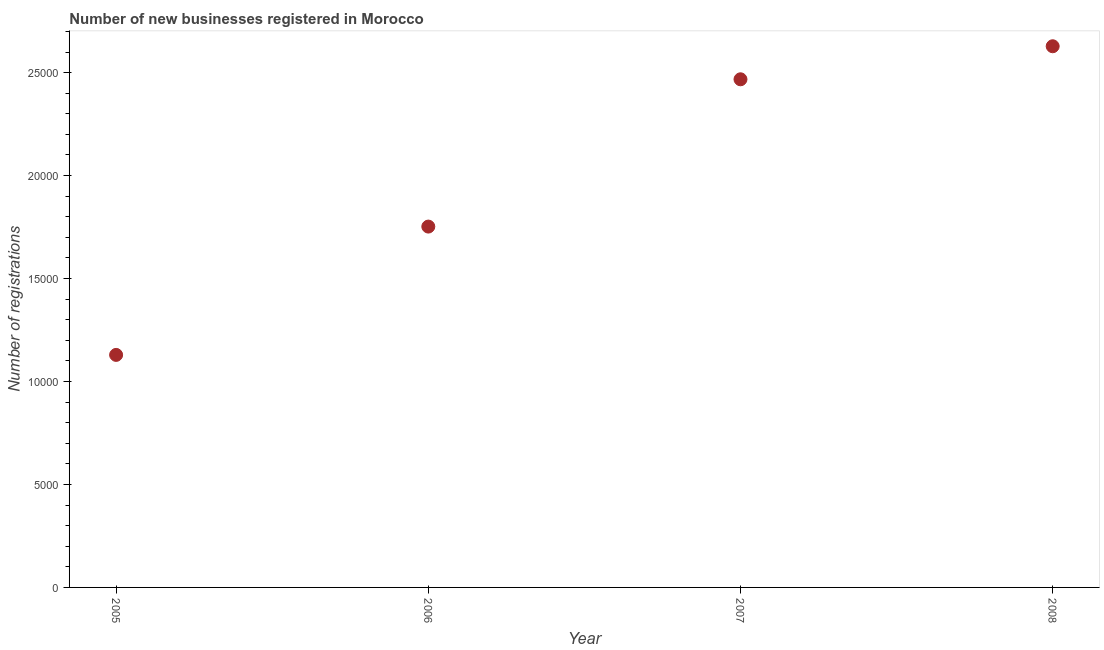What is the number of new business registrations in 2007?
Give a very brief answer. 2.47e+04. Across all years, what is the maximum number of new business registrations?
Your answer should be compact. 2.63e+04. Across all years, what is the minimum number of new business registrations?
Give a very brief answer. 1.13e+04. In which year was the number of new business registrations maximum?
Your answer should be compact. 2008. In which year was the number of new business registrations minimum?
Provide a short and direct response. 2005. What is the sum of the number of new business registrations?
Offer a very short reply. 7.98e+04. What is the difference between the number of new business registrations in 2005 and 2007?
Your answer should be compact. -1.34e+04. What is the average number of new business registrations per year?
Your answer should be compact. 1.99e+04. What is the median number of new business registrations?
Make the answer very short. 2.11e+04. In how many years, is the number of new business registrations greater than 26000 ?
Your answer should be compact. 1. Do a majority of the years between 2006 and 2007 (inclusive) have number of new business registrations greater than 18000 ?
Your answer should be very brief. No. What is the ratio of the number of new business registrations in 2005 to that in 2006?
Your answer should be compact. 0.64. What is the difference between the highest and the second highest number of new business registrations?
Give a very brief answer. 1604. What is the difference between the highest and the lowest number of new business registrations?
Keep it short and to the point. 1.50e+04. In how many years, is the number of new business registrations greater than the average number of new business registrations taken over all years?
Ensure brevity in your answer.  2. How many years are there in the graph?
Give a very brief answer. 4. What is the difference between two consecutive major ticks on the Y-axis?
Give a very brief answer. 5000. Does the graph contain grids?
Provide a short and direct response. No. What is the title of the graph?
Your answer should be compact. Number of new businesses registered in Morocco. What is the label or title of the X-axis?
Your response must be concise. Year. What is the label or title of the Y-axis?
Provide a succinct answer. Number of registrations. What is the Number of registrations in 2005?
Keep it short and to the point. 1.13e+04. What is the Number of registrations in 2006?
Ensure brevity in your answer.  1.75e+04. What is the Number of registrations in 2007?
Offer a terse response. 2.47e+04. What is the Number of registrations in 2008?
Ensure brevity in your answer.  2.63e+04. What is the difference between the Number of registrations in 2005 and 2006?
Give a very brief answer. -6231. What is the difference between the Number of registrations in 2005 and 2007?
Your response must be concise. -1.34e+04. What is the difference between the Number of registrations in 2005 and 2008?
Your response must be concise. -1.50e+04. What is the difference between the Number of registrations in 2006 and 2007?
Offer a terse response. -7153. What is the difference between the Number of registrations in 2006 and 2008?
Keep it short and to the point. -8757. What is the difference between the Number of registrations in 2007 and 2008?
Your answer should be very brief. -1604. What is the ratio of the Number of registrations in 2005 to that in 2006?
Provide a succinct answer. 0.64. What is the ratio of the Number of registrations in 2005 to that in 2007?
Provide a succinct answer. 0.46. What is the ratio of the Number of registrations in 2005 to that in 2008?
Give a very brief answer. 0.43. What is the ratio of the Number of registrations in 2006 to that in 2007?
Provide a succinct answer. 0.71. What is the ratio of the Number of registrations in 2006 to that in 2008?
Ensure brevity in your answer.  0.67. What is the ratio of the Number of registrations in 2007 to that in 2008?
Your response must be concise. 0.94. 